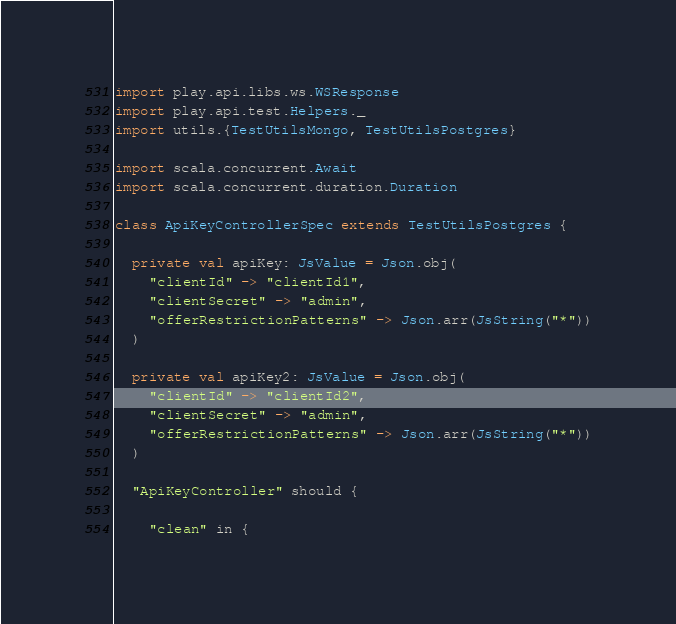<code> <loc_0><loc_0><loc_500><loc_500><_Scala_>import play.api.libs.ws.WSResponse
import play.api.test.Helpers._
import utils.{TestUtilsMongo, TestUtilsPostgres}

import scala.concurrent.Await
import scala.concurrent.duration.Duration

class ApiKeyControllerSpec extends TestUtilsPostgres {

  private val apiKey: JsValue = Json.obj(
    "clientId" -> "clientId1",
    "clientSecret" -> "admin",
    "offerRestrictionPatterns" -> Json.arr(JsString("*"))
  )

  private val apiKey2: JsValue = Json.obj(
    "clientId" -> "clientId2",
    "clientSecret" -> "admin",
    "offerRestrictionPatterns" -> Json.arr(JsString("*"))
  )

  "ApiKeyController" should {

    "clean" in {</code> 